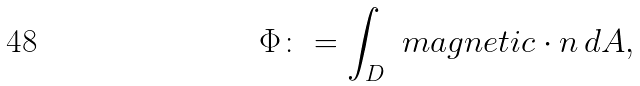Convert formula to latex. <formula><loc_0><loc_0><loc_500><loc_500>\Phi \colon = \int _ { D } \ m a g n e t i c \cdot n \, d A ,</formula> 